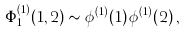Convert formula to latex. <formula><loc_0><loc_0><loc_500><loc_500>\Phi _ { 1 } ^ { ( 1 ) } ( 1 , 2 ) \sim \phi ^ { ( 1 ) } ( 1 ) \, \phi ^ { ( 1 ) } ( 2 ) \, ,</formula> 